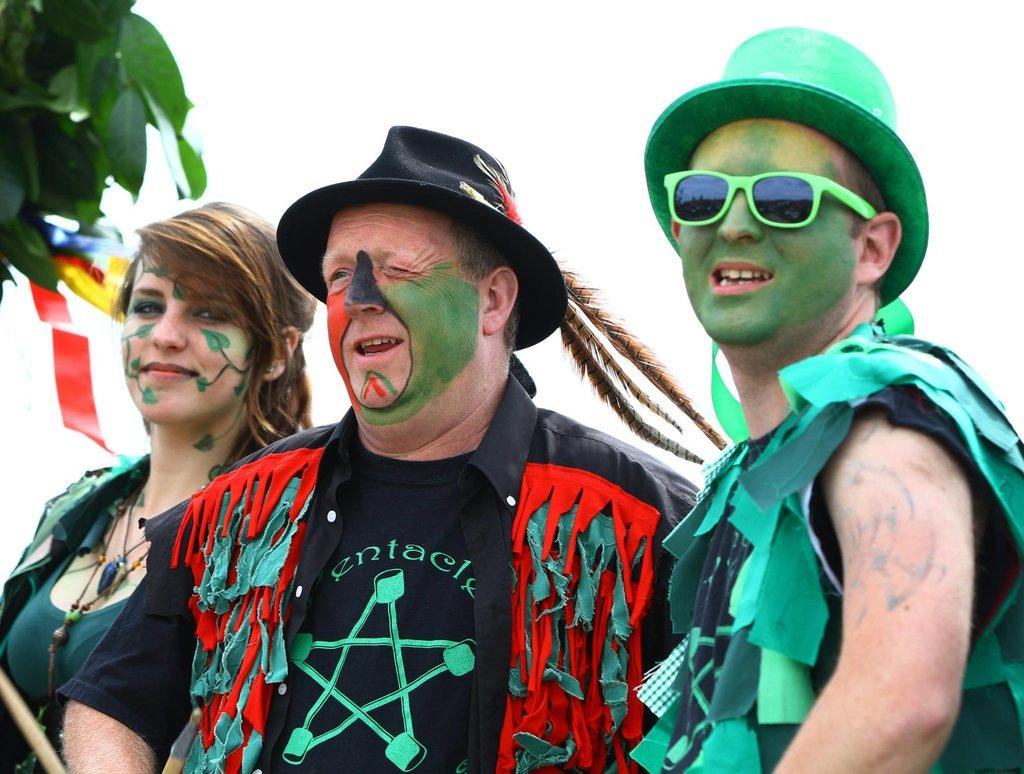How many people are in the image? There are three persons in the image. Can you describe the gender of the persons? One of the persons is a lady, and the other two are men. What is unique about the appearance of the persons? The faces of all three persons are painted with colors. How are the persons dressed? The persons are dressed in a different manner. What type of system is being discussed by the persons in the image? There is no indication in the image that the persons are discussing any system. Can you tell me how the cart is being used by the persons in the image? There is no cart present in the image; it only features three persons with painted faces and different clothing. 